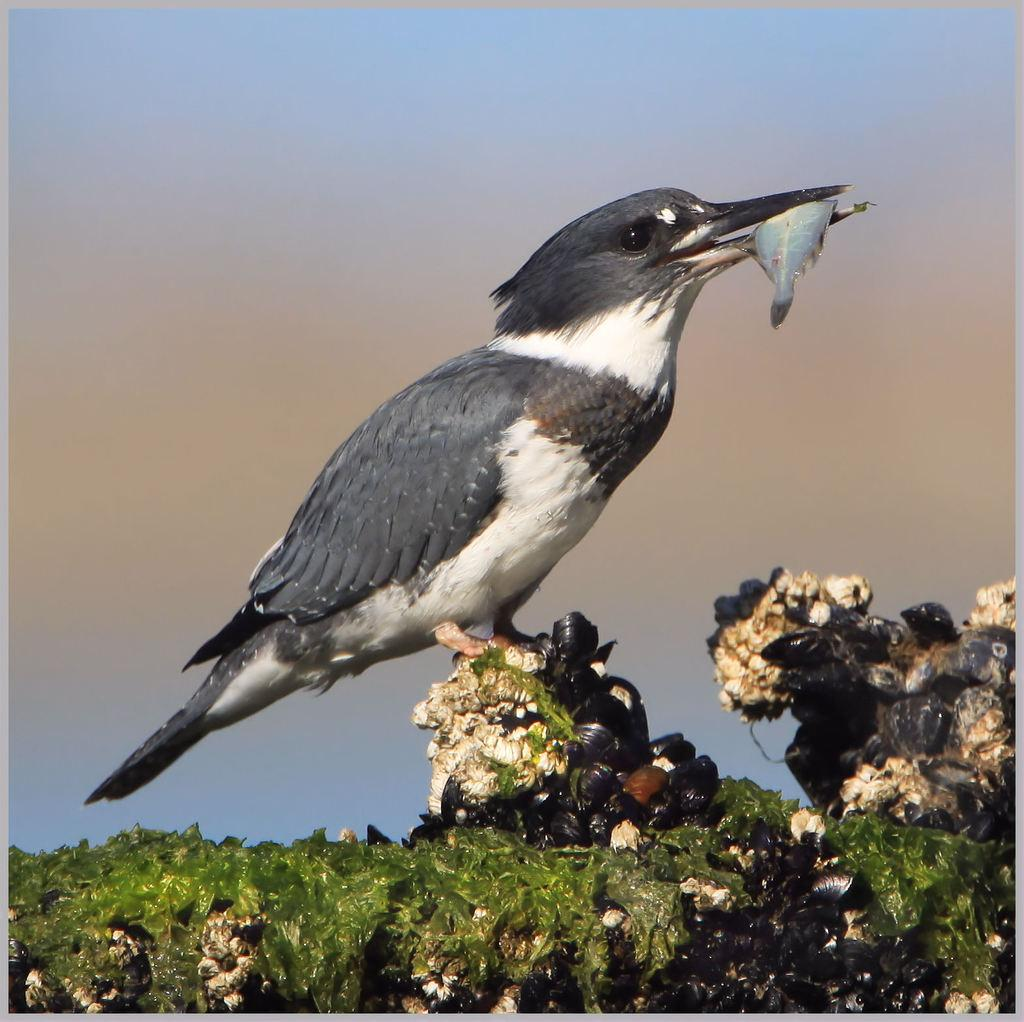What type of animal can be seen in the image? There is a bird in the image. What is the bird doing with its mouth? The bird is holding a fish in its mouth. What is the bird standing on? The bird is standing on some objects. What type of flag is the bird waving in the image? There is no flag present in the image; the bird is holding a fish in its mouth and standing on some objects. 